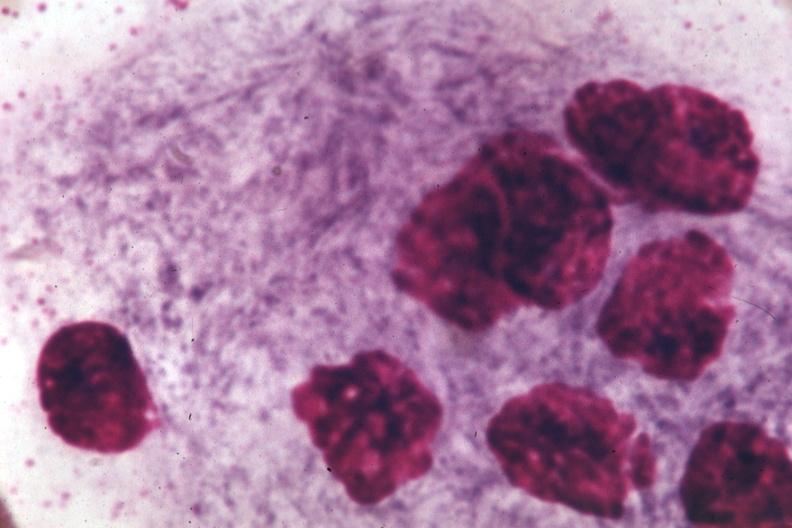s bone marrow present?
Answer the question using a single word or phrase. Yes 